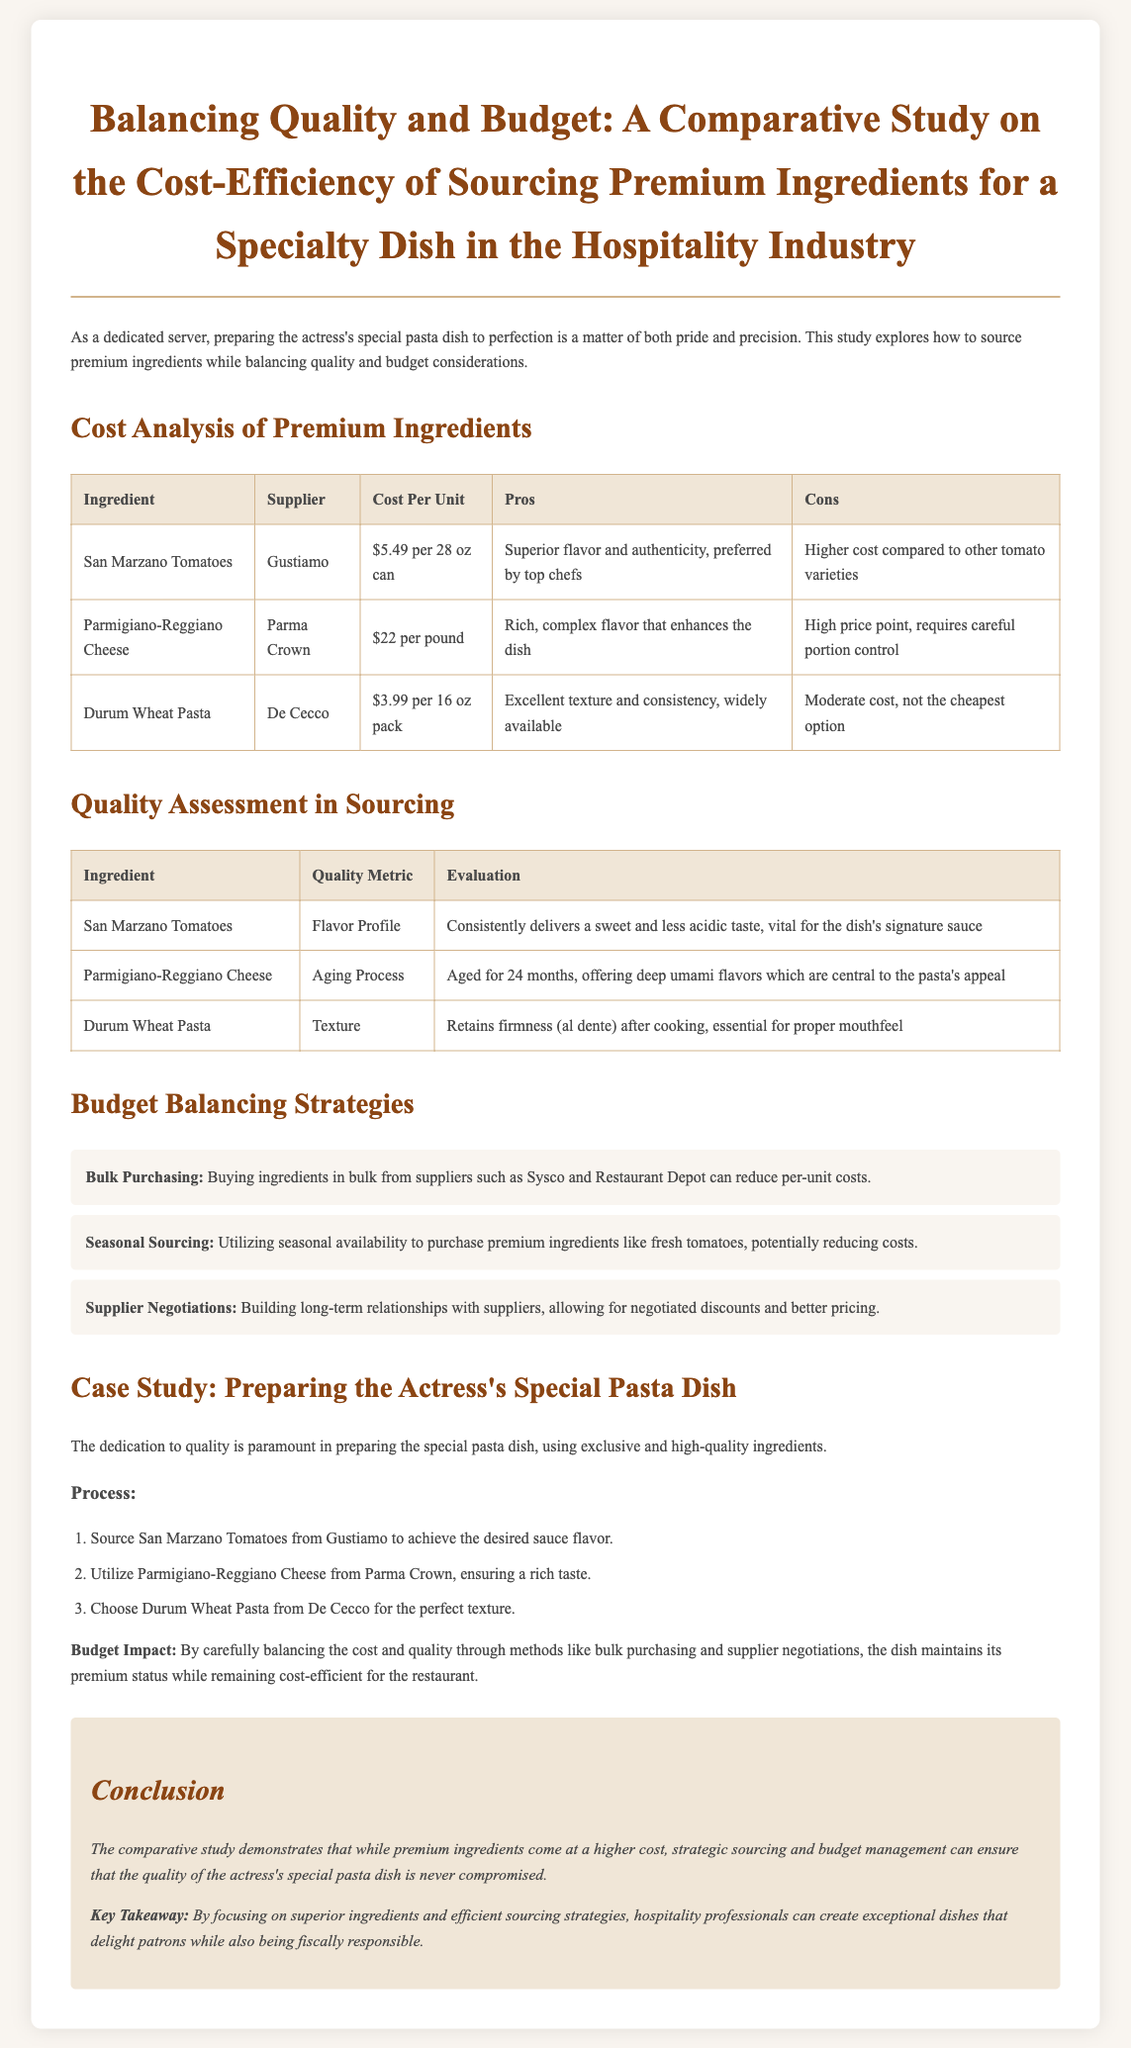What is the cost of San Marzano Tomatoes? The cost of San Marzano Tomatoes per 28 oz can is $5.49.
Answer: $5.49 Who is the supplier of Parmigiano-Reggiano Cheese? The supplier listed for Parmigiano-Reggiano Cheese is Parma Crown.
Answer: Parma Crown What is the quality metric for Durum Wheat Pasta? The quality metric for Durum Wheat Pasta is Texture.
Answer: Texture What are the three strategies for budget balancing mentioned? The strategies listed are Bulk Purchasing, Seasonal Sourcing, and Supplier Negotiations.
Answer: Bulk Purchasing, Seasonal Sourcing, Supplier Negotiations How long is Parmigiano-Reggiano Cheese aged? Parmigiano-Reggiano Cheese is aged for 24 months.
Answer: 24 months What is the main appeal of using San Marzano Tomatoes in the dish? The main appeal is its superior flavor and authenticity.
Answer: Superior flavor and authenticity Which ingredient is sourced to achieve the desired sauce flavor? San Marzano Tomatoes are sourced to achieve the desired sauce flavor.
Answer: San Marzano Tomatoes What impact does careful cost and quality balancing have on the dish? The impact is that the dish maintains its premium status while being cost-efficient.
Answer: Premium status while being cost-efficient 